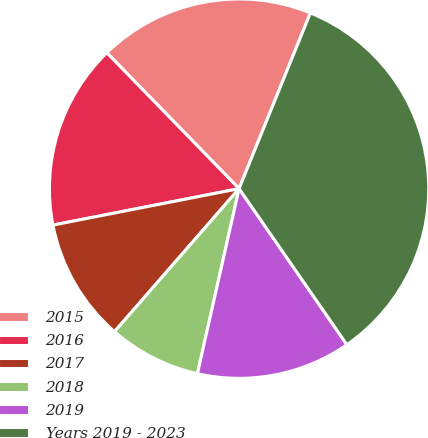Convert chart to OTSL. <chart><loc_0><loc_0><loc_500><loc_500><pie_chart><fcel>2015<fcel>2016<fcel>2017<fcel>2018<fcel>2019<fcel>Years 2019 - 2023<nl><fcel>18.42%<fcel>15.79%<fcel>10.52%<fcel>7.88%<fcel>13.15%<fcel>34.24%<nl></chart> 